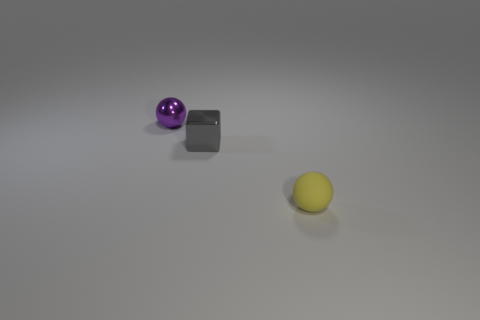How do the objects seem positioned relative to each other? The objects are positioned at varying distances from the viewer's perspective. The purple sphere is the closest to the camera, followed by the gray block, which is slightly behind and to the left of the sphere. The yellow object is the furthest away, off to the right side, creating a triangular formation that adds depth to the composition. 